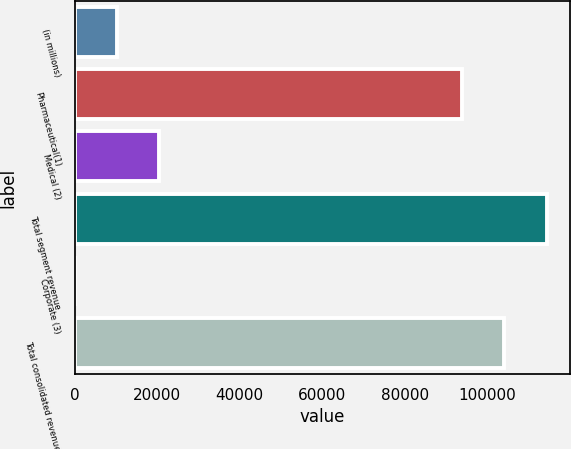<chart> <loc_0><loc_0><loc_500><loc_500><bar_chart><fcel>(in millions)<fcel>Pharmaceutical(1)<fcel>Medical (2)<fcel>Total segment revenue<fcel>Corporate (3)<fcel>Total consolidated revenue<nl><fcel>10285.2<fcel>93743.5<fcel>20549.6<fcel>114272<fcel>20.8<fcel>104008<nl></chart> 